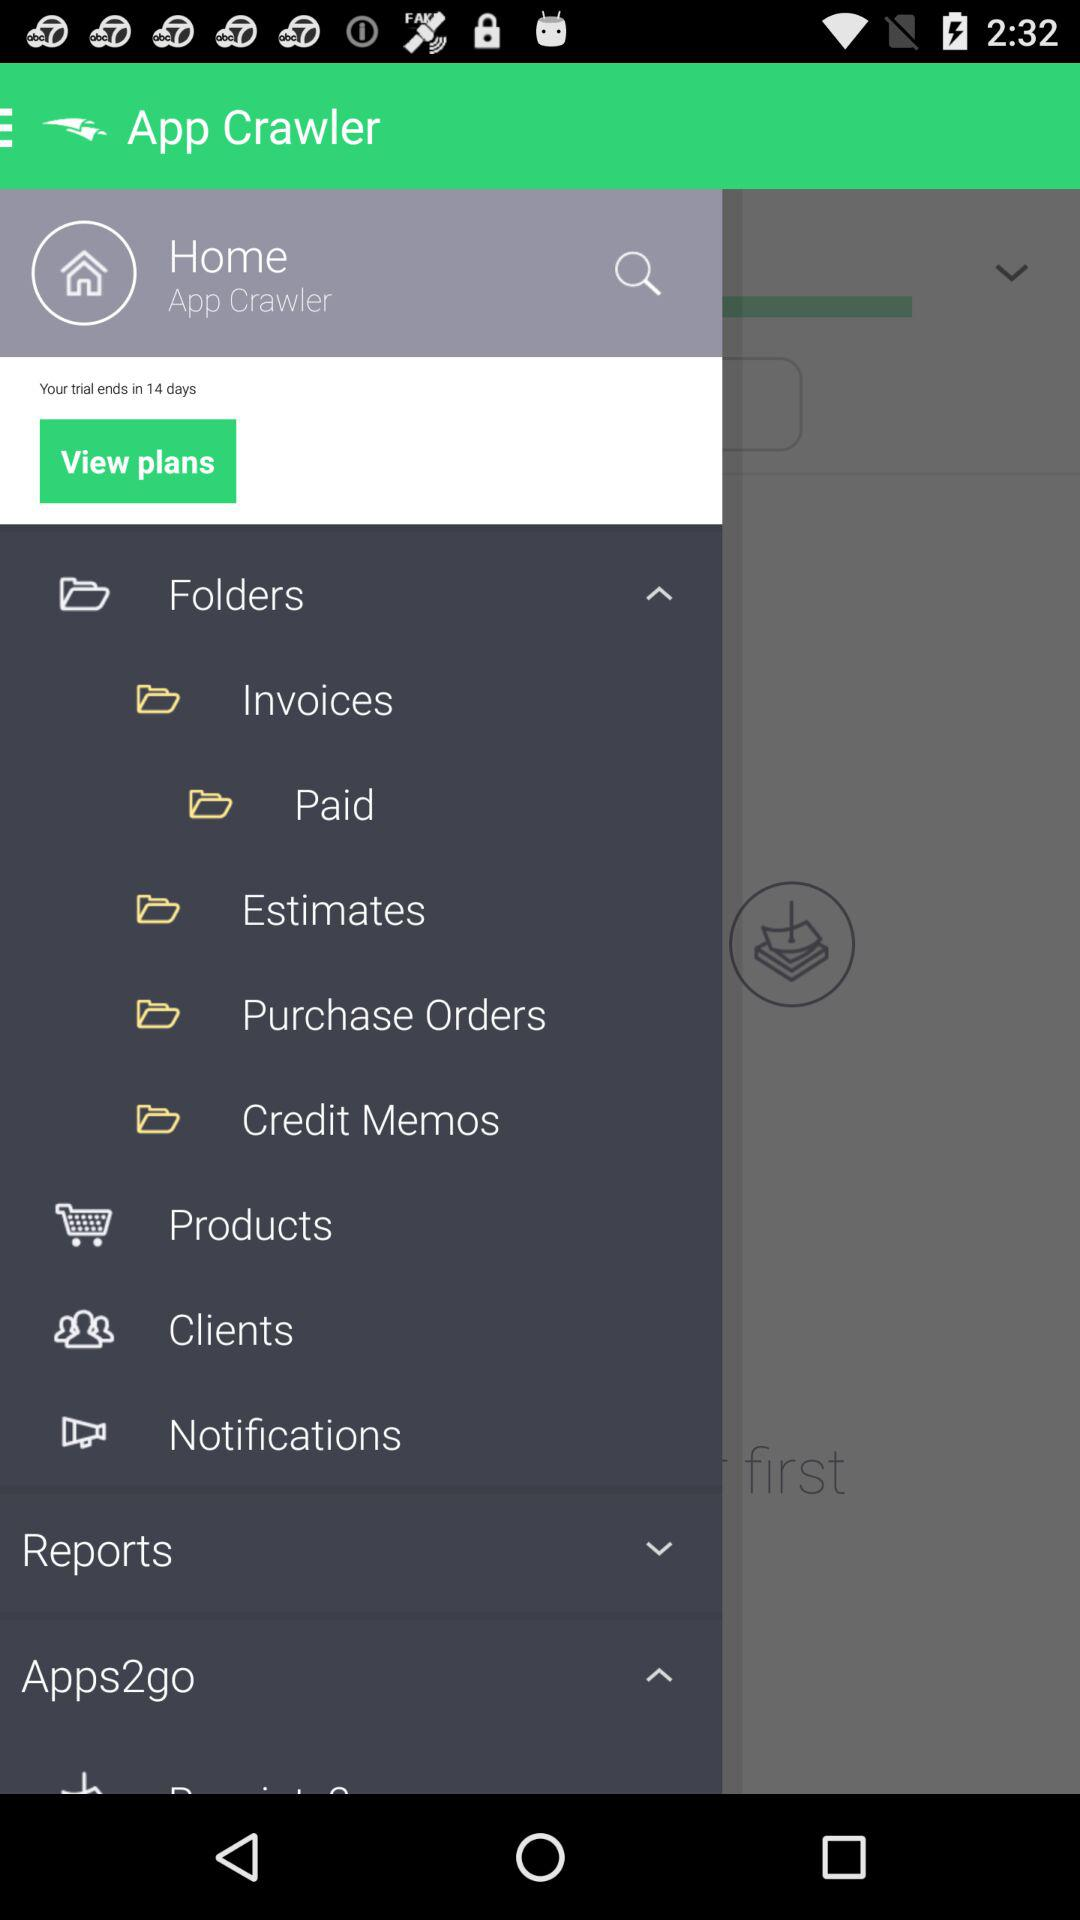In how many days will the trial end? The trial will end in 14 days. 